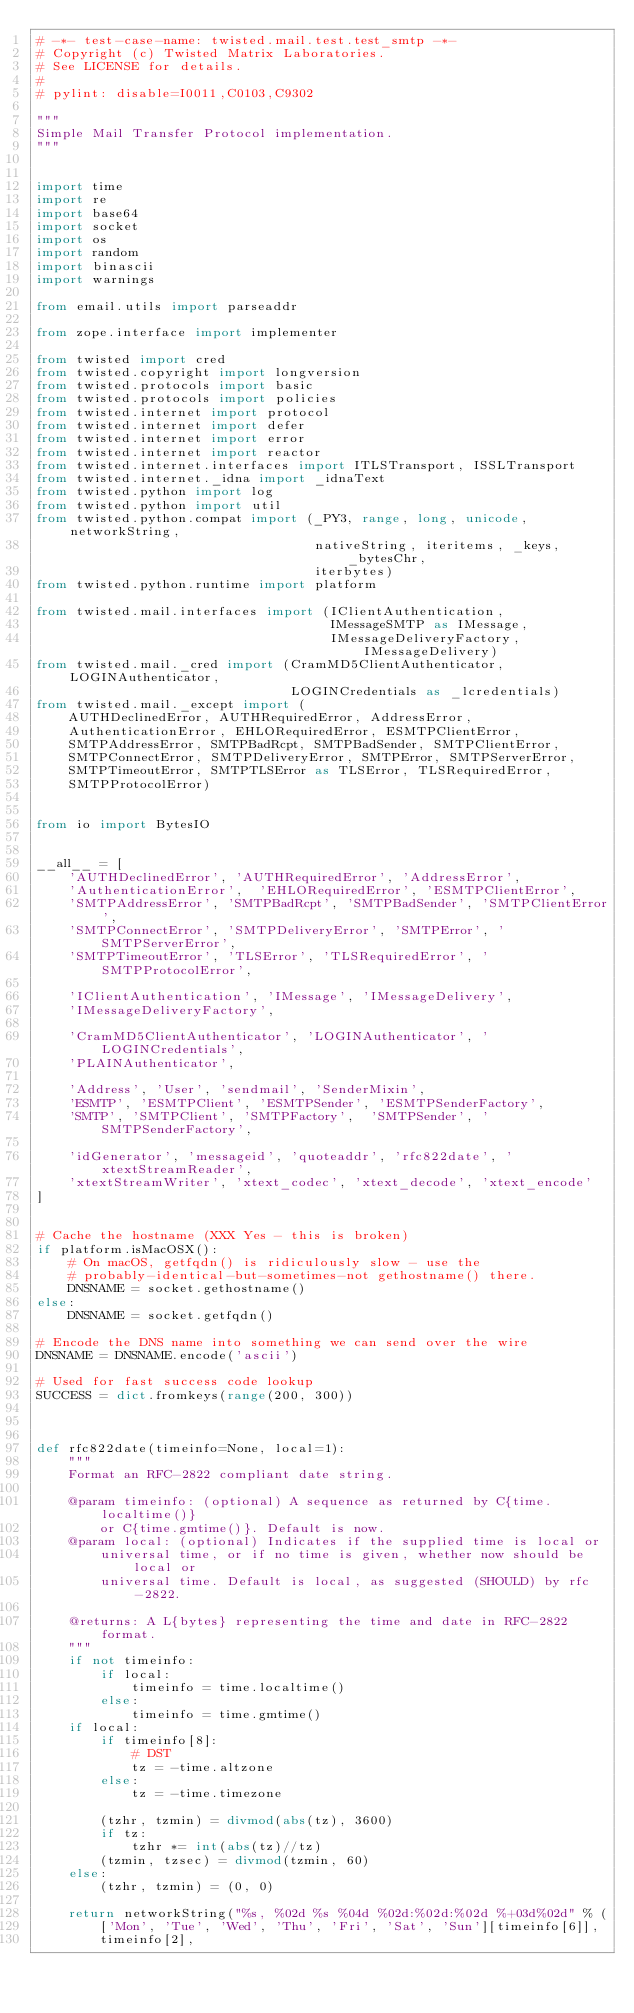Convert code to text. <code><loc_0><loc_0><loc_500><loc_500><_Python_># -*- test-case-name: twisted.mail.test.test_smtp -*-
# Copyright (c) Twisted Matrix Laboratories.
# See LICENSE for details.
#
# pylint: disable=I0011,C0103,C9302

"""
Simple Mail Transfer Protocol implementation.
"""


import time
import re
import base64
import socket
import os
import random
import binascii
import warnings

from email.utils import parseaddr

from zope.interface import implementer

from twisted import cred
from twisted.copyright import longversion
from twisted.protocols import basic
from twisted.protocols import policies
from twisted.internet import protocol
from twisted.internet import defer
from twisted.internet import error
from twisted.internet import reactor
from twisted.internet.interfaces import ITLSTransport, ISSLTransport
from twisted.internet._idna import _idnaText
from twisted.python import log
from twisted.python import util
from twisted.python.compat import (_PY3, range, long, unicode, networkString,
                                   nativeString, iteritems, _keys, _bytesChr,
                                   iterbytes)
from twisted.python.runtime import platform

from twisted.mail.interfaces import (IClientAuthentication,
                                     IMessageSMTP as IMessage,
                                     IMessageDeliveryFactory, IMessageDelivery)
from twisted.mail._cred import (CramMD5ClientAuthenticator, LOGINAuthenticator,
                                LOGINCredentials as _lcredentials)
from twisted.mail._except import (
    AUTHDeclinedError, AUTHRequiredError, AddressError,
    AuthenticationError, EHLORequiredError, ESMTPClientError,
    SMTPAddressError, SMTPBadRcpt, SMTPBadSender, SMTPClientError,
    SMTPConnectError, SMTPDeliveryError, SMTPError, SMTPServerError,
    SMTPTimeoutError, SMTPTLSError as TLSError, TLSRequiredError,
    SMTPProtocolError)


from io import BytesIO


__all__ = [
    'AUTHDeclinedError', 'AUTHRequiredError', 'AddressError',
    'AuthenticationError',  'EHLORequiredError', 'ESMTPClientError',
    'SMTPAddressError', 'SMTPBadRcpt', 'SMTPBadSender', 'SMTPClientError',
    'SMTPConnectError', 'SMTPDeliveryError', 'SMTPError', 'SMTPServerError',
    'SMTPTimeoutError', 'TLSError', 'TLSRequiredError', 'SMTPProtocolError',

    'IClientAuthentication', 'IMessage', 'IMessageDelivery',
    'IMessageDeliveryFactory',

    'CramMD5ClientAuthenticator', 'LOGINAuthenticator', 'LOGINCredentials',
    'PLAINAuthenticator',

    'Address', 'User', 'sendmail', 'SenderMixin',
    'ESMTP', 'ESMTPClient', 'ESMTPSender', 'ESMTPSenderFactory',
    'SMTP', 'SMTPClient', 'SMTPFactory',  'SMTPSender', 'SMTPSenderFactory',

    'idGenerator', 'messageid', 'quoteaddr', 'rfc822date', 'xtextStreamReader',
    'xtextStreamWriter', 'xtext_codec', 'xtext_decode', 'xtext_encode'
]


# Cache the hostname (XXX Yes - this is broken)
if platform.isMacOSX():
    # On macOS, getfqdn() is ridiculously slow - use the
    # probably-identical-but-sometimes-not gethostname() there.
    DNSNAME = socket.gethostname()
else:
    DNSNAME = socket.getfqdn()

# Encode the DNS name into something we can send over the wire
DNSNAME = DNSNAME.encode('ascii')

# Used for fast success code lookup
SUCCESS = dict.fromkeys(range(200, 300))



def rfc822date(timeinfo=None, local=1):
    """
    Format an RFC-2822 compliant date string.

    @param timeinfo: (optional) A sequence as returned by C{time.localtime()}
        or C{time.gmtime()}. Default is now.
    @param local: (optional) Indicates if the supplied time is local or
        universal time, or if no time is given, whether now should be local or
        universal time. Default is local, as suggested (SHOULD) by rfc-2822.

    @returns: A L{bytes} representing the time and date in RFC-2822 format.
    """
    if not timeinfo:
        if local:
            timeinfo = time.localtime()
        else:
            timeinfo = time.gmtime()
    if local:
        if timeinfo[8]:
            # DST
            tz = -time.altzone
        else:
            tz = -time.timezone

        (tzhr, tzmin) = divmod(abs(tz), 3600)
        if tz:
            tzhr *= int(abs(tz)//tz)
        (tzmin, tzsec) = divmod(tzmin, 60)
    else:
        (tzhr, tzmin) = (0, 0)

    return networkString("%s, %02d %s %04d %02d:%02d:%02d %+03d%02d" % (
        ['Mon', 'Tue', 'Wed', 'Thu', 'Fri', 'Sat', 'Sun'][timeinfo[6]],
        timeinfo[2],</code> 